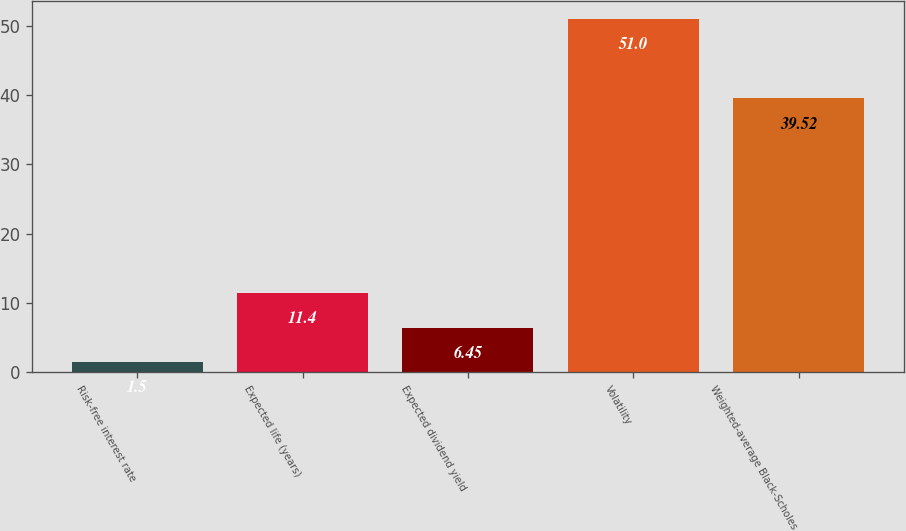Convert chart to OTSL. <chart><loc_0><loc_0><loc_500><loc_500><bar_chart><fcel>Risk-free interest rate<fcel>Expected life (years)<fcel>Expected dividend yield<fcel>Volatility<fcel>Weighted-average Black-Scholes<nl><fcel>1.5<fcel>11.4<fcel>6.45<fcel>51<fcel>39.52<nl></chart> 